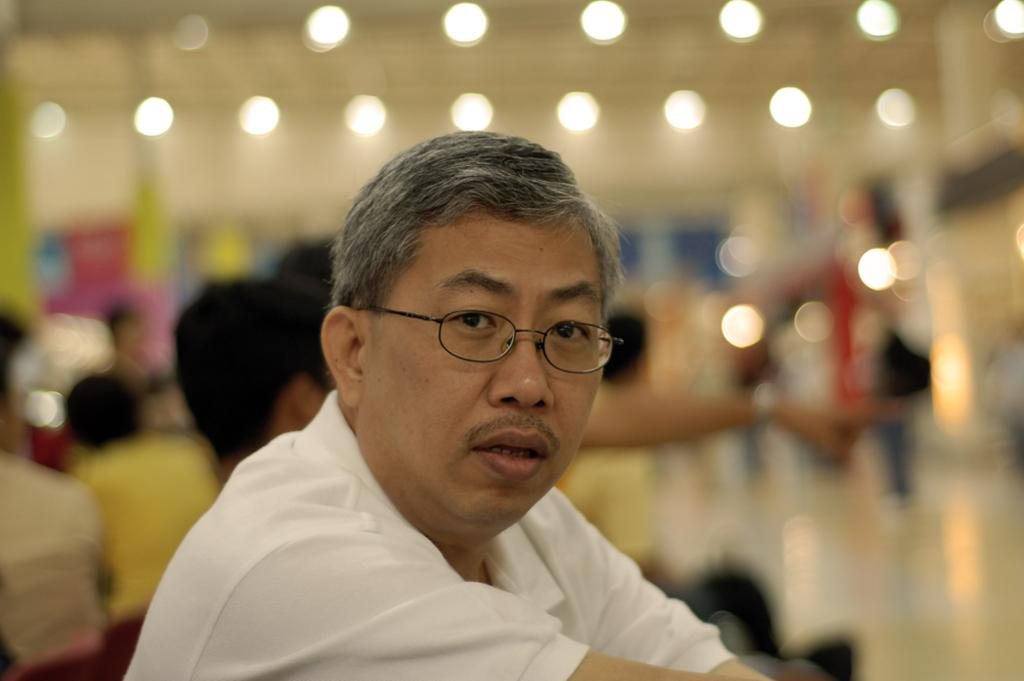Who is present in the image? There is a man in the image. What is the man wearing? The man is wearing a white t-shirt. What can be seen behind the man? There are blurred objects and people visible behind the man. What can be observed in terms of lighting in the image? There are lights visible in the image. What type of destruction can be seen happening in the image? There is no destruction present in the image; it features a man wearing a white t-shirt with blurred objects and people behind him. What does the man's tongue look like in the image? The image does not show the man's tongue, so it cannot be described. 